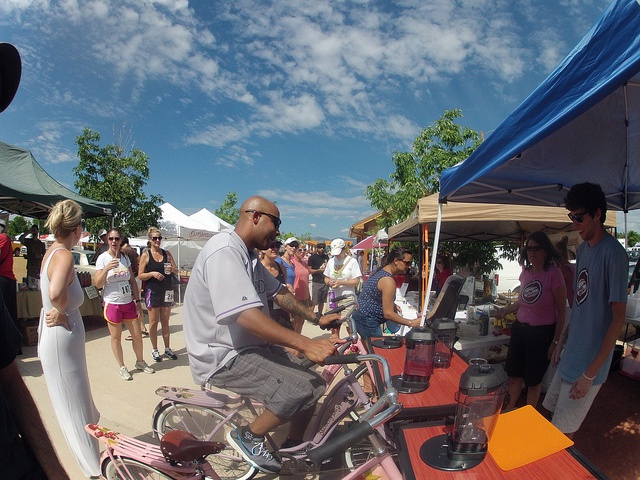Describe the objects in this image and their specific colors. I can see people in lightgray, gray, and darkgray tones, dining table in lightgray, black, brown, and maroon tones, people in lightgray, black, gray, and maroon tones, people in lightgray, gray, darkgray, and tan tones, and bicycle in lightgray, gray, darkgray, and black tones in this image. 